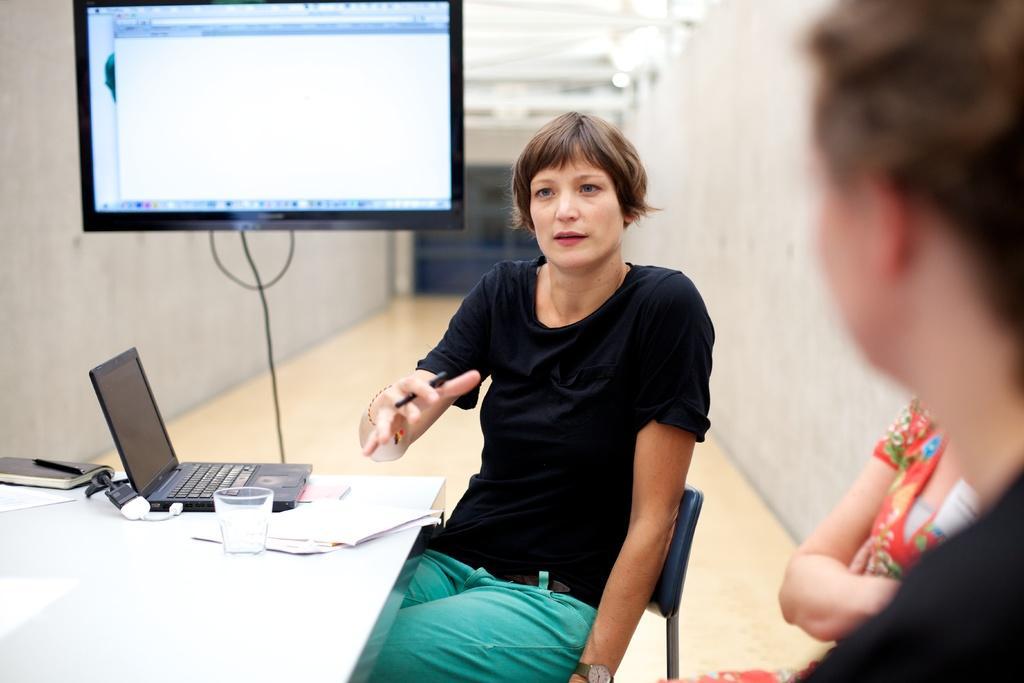How would you summarize this image in a sentence or two? This picture describes about few people, they are all seated on the chair, in the middle of the image a woman is holding a pen in her hand, in front of her we can see glass, laptop, book on the table in the background we can see a television. 